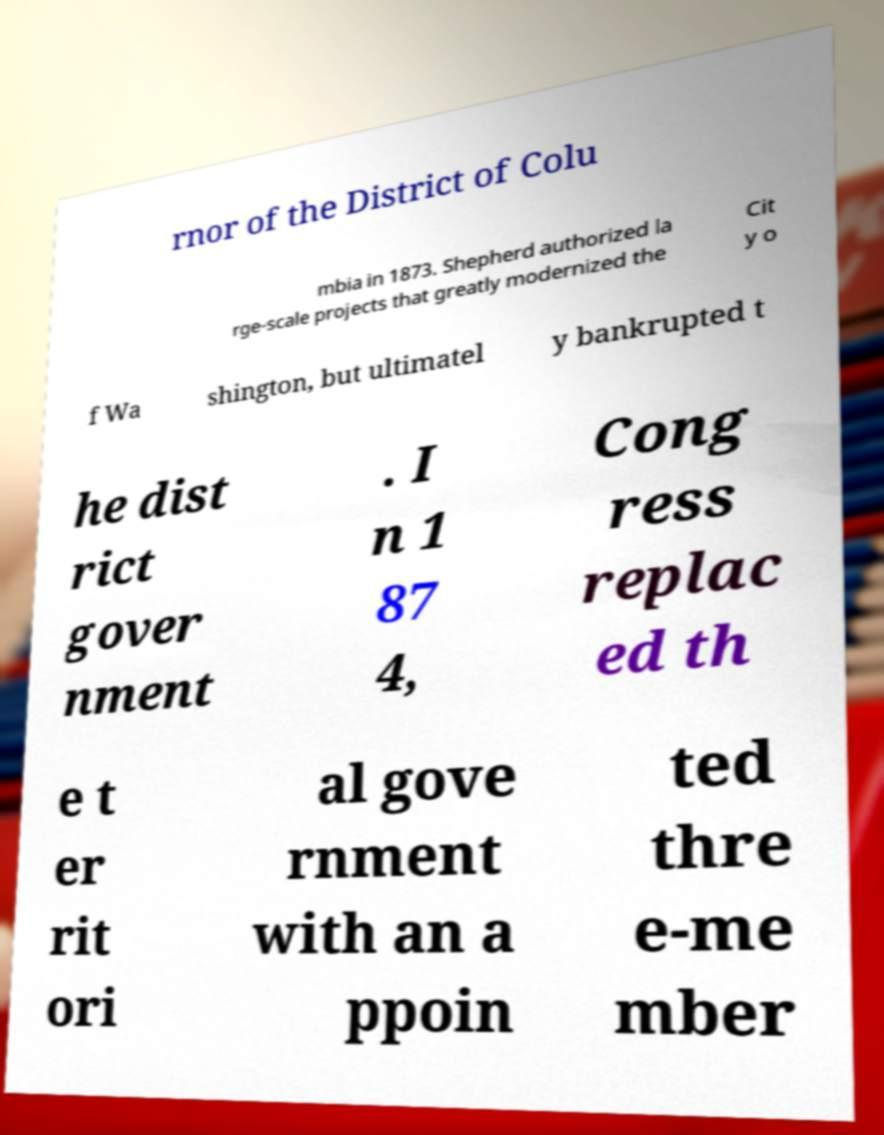For documentation purposes, I need the text within this image transcribed. Could you provide that? rnor of the District of Colu mbia in 1873. Shepherd authorized la rge-scale projects that greatly modernized the Cit y o f Wa shington, but ultimatel y bankrupted t he dist rict gover nment . I n 1 87 4, Cong ress replac ed th e t er rit ori al gove rnment with an a ppoin ted thre e-me mber 